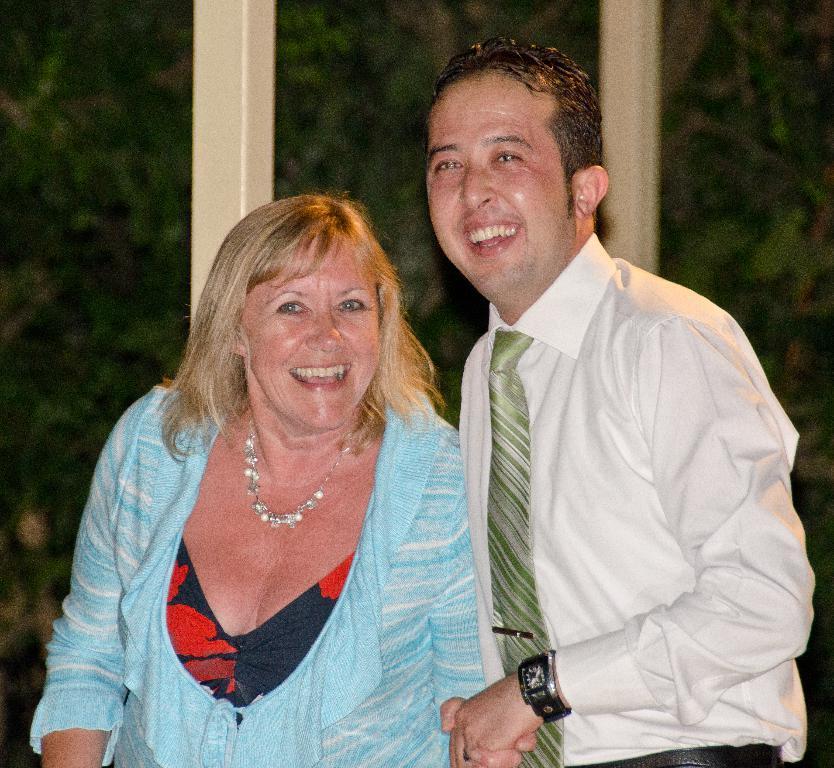Describe this image in one or two sentences. In this image we can see a man and a lady standing and smiling. In the background there are trees and rods. 